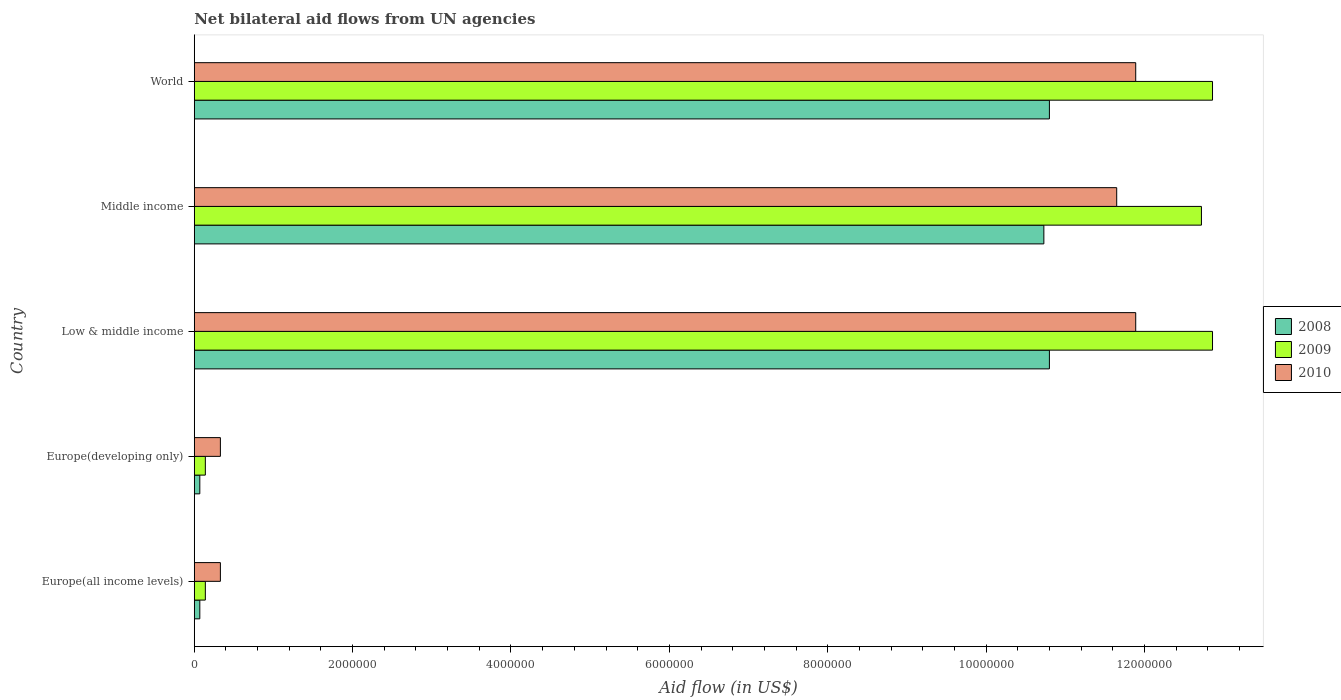Are the number of bars on each tick of the Y-axis equal?
Your response must be concise. Yes. How many bars are there on the 4th tick from the bottom?
Your response must be concise. 3. What is the label of the 4th group of bars from the top?
Provide a short and direct response. Europe(developing only). In how many cases, is the number of bars for a given country not equal to the number of legend labels?
Your response must be concise. 0. Across all countries, what is the maximum net bilateral aid flow in 2009?
Your response must be concise. 1.29e+07. Across all countries, what is the minimum net bilateral aid flow in 2009?
Offer a terse response. 1.40e+05. In which country was the net bilateral aid flow in 2010 minimum?
Offer a very short reply. Europe(all income levels). What is the total net bilateral aid flow in 2008 in the graph?
Provide a short and direct response. 3.25e+07. What is the difference between the net bilateral aid flow in 2009 in Europe(all income levels) and that in Middle income?
Your answer should be compact. -1.26e+07. What is the difference between the net bilateral aid flow in 2010 in World and the net bilateral aid flow in 2008 in Low & middle income?
Your answer should be very brief. 1.09e+06. What is the average net bilateral aid flow in 2010 per country?
Provide a short and direct response. 7.22e+06. What is the difference between the net bilateral aid flow in 2008 and net bilateral aid flow in 2010 in Low & middle income?
Your answer should be compact. -1.09e+06. What is the ratio of the net bilateral aid flow in 2009 in Europe(all income levels) to that in Europe(developing only)?
Your response must be concise. 1. What is the difference between the highest and the second highest net bilateral aid flow in 2008?
Ensure brevity in your answer.  0. What is the difference between the highest and the lowest net bilateral aid flow in 2010?
Your response must be concise. 1.16e+07. Is the sum of the net bilateral aid flow in 2010 in Europe(all income levels) and Middle income greater than the maximum net bilateral aid flow in 2009 across all countries?
Offer a terse response. No. What does the 3rd bar from the top in Europe(developing only) represents?
Your answer should be compact. 2008. What does the 3rd bar from the bottom in Europe(all income levels) represents?
Ensure brevity in your answer.  2010. How many bars are there?
Ensure brevity in your answer.  15. Are all the bars in the graph horizontal?
Ensure brevity in your answer.  Yes. What is the difference between two consecutive major ticks on the X-axis?
Ensure brevity in your answer.  2.00e+06. Are the values on the major ticks of X-axis written in scientific E-notation?
Ensure brevity in your answer.  No. Does the graph contain any zero values?
Offer a very short reply. No. Where does the legend appear in the graph?
Offer a very short reply. Center right. What is the title of the graph?
Make the answer very short. Net bilateral aid flows from UN agencies. Does "1963" appear as one of the legend labels in the graph?
Make the answer very short. No. What is the label or title of the X-axis?
Make the answer very short. Aid flow (in US$). What is the label or title of the Y-axis?
Your answer should be compact. Country. What is the Aid flow (in US$) of 2008 in Europe(all income levels)?
Offer a very short reply. 7.00e+04. What is the Aid flow (in US$) of 2009 in Europe(all income levels)?
Ensure brevity in your answer.  1.40e+05. What is the Aid flow (in US$) of 2008 in Europe(developing only)?
Offer a terse response. 7.00e+04. What is the Aid flow (in US$) of 2008 in Low & middle income?
Give a very brief answer. 1.08e+07. What is the Aid flow (in US$) of 2009 in Low & middle income?
Keep it short and to the point. 1.29e+07. What is the Aid flow (in US$) of 2010 in Low & middle income?
Provide a succinct answer. 1.19e+07. What is the Aid flow (in US$) of 2008 in Middle income?
Your answer should be compact. 1.07e+07. What is the Aid flow (in US$) in 2009 in Middle income?
Provide a succinct answer. 1.27e+07. What is the Aid flow (in US$) in 2010 in Middle income?
Ensure brevity in your answer.  1.16e+07. What is the Aid flow (in US$) of 2008 in World?
Keep it short and to the point. 1.08e+07. What is the Aid flow (in US$) of 2009 in World?
Provide a succinct answer. 1.29e+07. What is the Aid flow (in US$) in 2010 in World?
Keep it short and to the point. 1.19e+07. Across all countries, what is the maximum Aid flow (in US$) of 2008?
Your answer should be very brief. 1.08e+07. Across all countries, what is the maximum Aid flow (in US$) in 2009?
Keep it short and to the point. 1.29e+07. Across all countries, what is the maximum Aid flow (in US$) of 2010?
Provide a short and direct response. 1.19e+07. Across all countries, what is the minimum Aid flow (in US$) of 2009?
Provide a short and direct response. 1.40e+05. What is the total Aid flow (in US$) in 2008 in the graph?
Provide a short and direct response. 3.25e+07. What is the total Aid flow (in US$) in 2009 in the graph?
Provide a succinct answer. 3.87e+07. What is the total Aid flow (in US$) of 2010 in the graph?
Your answer should be compact. 3.61e+07. What is the difference between the Aid flow (in US$) of 2008 in Europe(all income levels) and that in Europe(developing only)?
Your answer should be compact. 0. What is the difference between the Aid flow (in US$) in 2009 in Europe(all income levels) and that in Europe(developing only)?
Your answer should be compact. 0. What is the difference between the Aid flow (in US$) in 2010 in Europe(all income levels) and that in Europe(developing only)?
Ensure brevity in your answer.  0. What is the difference between the Aid flow (in US$) of 2008 in Europe(all income levels) and that in Low & middle income?
Your response must be concise. -1.07e+07. What is the difference between the Aid flow (in US$) in 2009 in Europe(all income levels) and that in Low & middle income?
Provide a short and direct response. -1.27e+07. What is the difference between the Aid flow (in US$) of 2010 in Europe(all income levels) and that in Low & middle income?
Offer a terse response. -1.16e+07. What is the difference between the Aid flow (in US$) of 2008 in Europe(all income levels) and that in Middle income?
Make the answer very short. -1.07e+07. What is the difference between the Aid flow (in US$) in 2009 in Europe(all income levels) and that in Middle income?
Provide a short and direct response. -1.26e+07. What is the difference between the Aid flow (in US$) of 2010 in Europe(all income levels) and that in Middle income?
Keep it short and to the point. -1.13e+07. What is the difference between the Aid flow (in US$) in 2008 in Europe(all income levels) and that in World?
Give a very brief answer. -1.07e+07. What is the difference between the Aid flow (in US$) in 2009 in Europe(all income levels) and that in World?
Give a very brief answer. -1.27e+07. What is the difference between the Aid flow (in US$) of 2010 in Europe(all income levels) and that in World?
Keep it short and to the point. -1.16e+07. What is the difference between the Aid flow (in US$) of 2008 in Europe(developing only) and that in Low & middle income?
Your response must be concise. -1.07e+07. What is the difference between the Aid flow (in US$) in 2009 in Europe(developing only) and that in Low & middle income?
Keep it short and to the point. -1.27e+07. What is the difference between the Aid flow (in US$) in 2010 in Europe(developing only) and that in Low & middle income?
Your response must be concise. -1.16e+07. What is the difference between the Aid flow (in US$) of 2008 in Europe(developing only) and that in Middle income?
Provide a short and direct response. -1.07e+07. What is the difference between the Aid flow (in US$) of 2009 in Europe(developing only) and that in Middle income?
Offer a very short reply. -1.26e+07. What is the difference between the Aid flow (in US$) in 2010 in Europe(developing only) and that in Middle income?
Ensure brevity in your answer.  -1.13e+07. What is the difference between the Aid flow (in US$) in 2008 in Europe(developing only) and that in World?
Provide a succinct answer. -1.07e+07. What is the difference between the Aid flow (in US$) of 2009 in Europe(developing only) and that in World?
Make the answer very short. -1.27e+07. What is the difference between the Aid flow (in US$) of 2010 in Europe(developing only) and that in World?
Your answer should be compact. -1.16e+07. What is the difference between the Aid flow (in US$) of 2010 in Low & middle income and that in Middle income?
Your response must be concise. 2.40e+05. What is the difference between the Aid flow (in US$) in 2008 in Low & middle income and that in World?
Provide a succinct answer. 0. What is the difference between the Aid flow (in US$) in 2009 in Low & middle income and that in World?
Give a very brief answer. 0. What is the difference between the Aid flow (in US$) of 2010 in Low & middle income and that in World?
Give a very brief answer. 0. What is the difference between the Aid flow (in US$) in 2008 in Middle income and that in World?
Offer a very short reply. -7.00e+04. What is the difference between the Aid flow (in US$) of 2010 in Middle income and that in World?
Your response must be concise. -2.40e+05. What is the difference between the Aid flow (in US$) of 2008 in Europe(all income levels) and the Aid flow (in US$) of 2009 in Low & middle income?
Your answer should be very brief. -1.28e+07. What is the difference between the Aid flow (in US$) in 2008 in Europe(all income levels) and the Aid flow (in US$) in 2010 in Low & middle income?
Your answer should be very brief. -1.18e+07. What is the difference between the Aid flow (in US$) in 2009 in Europe(all income levels) and the Aid flow (in US$) in 2010 in Low & middle income?
Give a very brief answer. -1.18e+07. What is the difference between the Aid flow (in US$) in 2008 in Europe(all income levels) and the Aid flow (in US$) in 2009 in Middle income?
Your response must be concise. -1.26e+07. What is the difference between the Aid flow (in US$) of 2008 in Europe(all income levels) and the Aid flow (in US$) of 2010 in Middle income?
Your answer should be compact. -1.16e+07. What is the difference between the Aid flow (in US$) in 2009 in Europe(all income levels) and the Aid flow (in US$) in 2010 in Middle income?
Your response must be concise. -1.15e+07. What is the difference between the Aid flow (in US$) in 2008 in Europe(all income levels) and the Aid flow (in US$) in 2009 in World?
Offer a terse response. -1.28e+07. What is the difference between the Aid flow (in US$) in 2008 in Europe(all income levels) and the Aid flow (in US$) in 2010 in World?
Offer a terse response. -1.18e+07. What is the difference between the Aid flow (in US$) of 2009 in Europe(all income levels) and the Aid flow (in US$) of 2010 in World?
Provide a short and direct response. -1.18e+07. What is the difference between the Aid flow (in US$) of 2008 in Europe(developing only) and the Aid flow (in US$) of 2009 in Low & middle income?
Give a very brief answer. -1.28e+07. What is the difference between the Aid flow (in US$) in 2008 in Europe(developing only) and the Aid flow (in US$) in 2010 in Low & middle income?
Provide a succinct answer. -1.18e+07. What is the difference between the Aid flow (in US$) of 2009 in Europe(developing only) and the Aid flow (in US$) of 2010 in Low & middle income?
Keep it short and to the point. -1.18e+07. What is the difference between the Aid flow (in US$) of 2008 in Europe(developing only) and the Aid flow (in US$) of 2009 in Middle income?
Offer a very short reply. -1.26e+07. What is the difference between the Aid flow (in US$) of 2008 in Europe(developing only) and the Aid flow (in US$) of 2010 in Middle income?
Offer a terse response. -1.16e+07. What is the difference between the Aid flow (in US$) of 2009 in Europe(developing only) and the Aid flow (in US$) of 2010 in Middle income?
Ensure brevity in your answer.  -1.15e+07. What is the difference between the Aid flow (in US$) of 2008 in Europe(developing only) and the Aid flow (in US$) of 2009 in World?
Offer a terse response. -1.28e+07. What is the difference between the Aid flow (in US$) of 2008 in Europe(developing only) and the Aid flow (in US$) of 2010 in World?
Provide a succinct answer. -1.18e+07. What is the difference between the Aid flow (in US$) of 2009 in Europe(developing only) and the Aid flow (in US$) of 2010 in World?
Your answer should be very brief. -1.18e+07. What is the difference between the Aid flow (in US$) in 2008 in Low & middle income and the Aid flow (in US$) in 2009 in Middle income?
Provide a succinct answer. -1.92e+06. What is the difference between the Aid flow (in US$) of 2008 in Low & middle income and the Aid flow (in US$) of 2010 in Middle income?
Offer a terse response. -8.50e+05. What is the difference between the Aid flow (in US$) of 2009 in Low & middle income and the Aid flow (in US$) of 2010 in Middle income?
Offer a very short reply. 1.21e+06. What is the difference between the Aid flow (in US$) of 2008 in Low & middle income and the Aid flow (in US$) of 2009 in World?
Your response must be concise. -2.06e+06. What is the difference between the Aid flow (in US$) in 2008 in Low & middle income and the Aid flow (in US$) in 2010 in World?
Provide a short and direct response. -1.09e+06. What is the difference between the Aid flow (in US$) of 2009 in Low & middle income and the Aid flow (in US$) of 2010 in World?
Keep it short and to the point. 9.70e+05. What is the difference between the Aid flow (in US$) of 2008 in Middle income and the Aid flow (in US$) of 2009 in World?
Your answer should be very brief. -2.13e+06. What is the difference between the Aid flow (in US$) of 2008 in Middle income and the Aid flow (in US$) of 2010 in World?
Your answer should be very brief. -1.16e+06. What is the difference between the Aid flow (in US$) of 2009 in Middle income and the Aid flow (in US$) of 2010 in World?
Keep it short and to the point. 8.30e+05. What is the average Aid flow (in US$) in 2008 per country?
Ensure brevity in your answer.  6.49e+06. What is the average Aid flow (in US$) of 2009 per country?
Give a very brief answer. 7.74e+06. What is the average Aid flow (in US$) in 2010 per country?
Your answer should be very brief. 7.22e+06. What is the difference between the Aid flow (in US$) in 2008 and Aid flow (in US$) in 2010 in Europe(all income levels)?
Make the answer very short. -2.60e+05. What is the difference between the Aid flow (in US$) in 2009 and Aid flow (in US$) in 2010 in Europe(all income levels)?
Your answer should be very brief. -1.90e+05. What is the difference between the Aid flow (in US$) of 2008 and Aid flow (in US$) of 2010 in Europe(developing only)?
Offer a very short reply. -2.60e+05. What is the difference between the Aid flow (in US$) of 2008 and Aid flow (in US$) of 2009 in Low & middle income?
Ensure brevity in your answer.  -2.06e+06. What is the difference between the Aid flow (in US$) of 2008 and Aid flow (in US$) of 2010 in Low & middle income?
Offer a terse response. -1.09e+06. What is the difference between the Aid flow (in US$) in 2009 and Aid flow (in US$) in 2010 in Low & middle income?
Keep it short and to the point. 9.70e+05. What is the difference between the Aid flow (in US$) in 2008 and Aid flow (in US$) in 2009 in Middle income?
Give a very brief answer. -1.99e+06. What is the difference between the Aid flow (in US$) of 2008 and Aid flow (in US$) of 2010 in Middle income?
Your answer should be very brief. -9.20e+05. What is the difference between the Aid flow (in US$) of 2009 and Aid flow (in US$) of 2010 in Middle income?
Keep it short and to the point. 1.07e+06. What is the difference between the Aid flow (in US$) of 2008 and Aid flow (in US$) of 2009 in World?
Provide a short and direct response. -2.06e+06. What is the difference between the Aid flow (in US$) of 2008 and Aid flow (in US$) of 2010 in World?
Offer a very short reply. -1.09e+06. What is the difference between the Aid flow (in US$) in 2009 and Aid flow (in US$) in 2010 in World?
Keep it short and to the point. 9.70e+05. What is the ratio of the Aid flow (in US$) in 2008 in Europe(all income levels) to that in Europe(developing only)?
Your answer should be very brief. 1. What is the ratio of the Aid flow (in US$) in 2009 in Europe(all income levels) to that in Europe(developing only)?
Your answer should be very brief. 1. What is the ratio of the Aid flow (in US$) in 2010 in Europe(all income levels) to that in Europe(developing only)?
Provide a succinct answer. 1. What is the ratio of the Aid flow (in US$) in 2008 in Europe(all income levels) to that in Low & middle income?
Ensure brevity in your answer.  0.01. What is the ratio of the Aid flow (in US$) in 2009 in Europe(all income levels) to that in Low & middle income?
Make the answer very short. 0.01. What is the ratio of the Aid flow (in US$) in 2010 in Europe(all income levels) to that in Low & middle income?
Provide a short and direct response. 0.03. What is the ratio of the Aid flow (in US$) in 2008 in Europe(all income levels) to that in Middle income?
Provide a succinct answer. 0.01. What is the ratio of the Aid flow (in US$) of 2009 in Europe(all income levels) to that in Middle income?
Offer a terse response. 0.01. What is the ratio of the Aid flow (in US$) of 2010 in Europe(all income levels) to that in Middle income?
Offer a very short reply. 0.03. What is the ratio of the Aid flow (in US$) in 2008 in Europe(all income levels) to that in World?
Offer a terse response. 0.01. What is the ratio of the Aid flow (in US$) of 2009 in Europe(all income levels) to that in World?
Your response must be concise. 0.01. What is the ratio of the Aid flow (in US$) of 2010 in Europe(all income levels) to that in World?
Provide a succinct answer. 0.03. What is the ratio of the Aid flow (in US$) of 2008 in Europe(developing only) to that in Low & middle income?
Your response must be concise. 0.01. What is the ratio of the Aid flow (in US$) of 2009 in Europe(developing only) to that in Low & middle income?
Provide a short and direct response. 0.01. What is the ratio of the Aid flow (in US$) of 2010 in Europe(developing only) to that in Low & middle income?
Keep it short and to the point. 0.03. What is the ratio of the Aid flow (in US$) of 2008 in Europe(developing only) to that in Middle income?
Offer a terse response. 0.01. What is the ratio of the Aid flow (in US$) in 2009 in Europe(developing only) to that in Middle income?
Your answer should be very brief. 0.01. What is the ratio of the Aid flow (in US$) of 2010 in Europe(developing only) to that in Middle income?
Your answer should be compact. 0.03. What is the ratio of the Aid flow (in US$) of 2008 in Europe(developing only) to that in World?
Offer a very short reply. 0.01. What is the ratio of the Aid flow (in US$) of 2009 in Europe(developing only) to that in World?
Ensure brevity in your answer.  0.01. What is the ratio of the Aid flow (in US$) in 2010 in Europe(developing only) to that in World?
Your answer should be compact. 0.03. What is the ratio of the Aid flow (in US$) of 2010 in Low & middle income to that in Middle income?
Your response must be concise. 1.02. What is the ratio of the Aid flow (in US$) in 2010 in Low & middle income to that in World?
Give a very brief answer. 1. What is the ratio of the Aid flow (in US$) in 2010 in Middle income to that in World?
Provide a short and direct response. 0.98. What is the difference between the highest and the second highest Aid flow (in US$) in 2010?
Offer a very short reply. 0. What is the difference between the highest and the lowest Aid flow (in US$) in 2008?
Provide a succinct answer. 1.07e+07. What is the difference between the highest and the lowest Aid flow (in US$) of 2009?
Make the answer very short. 1.27e+07. What is the difference between the highest and the lowest Aid flow (in US$) in 2010?
Provide a succinct answer. 1.16e+07. 